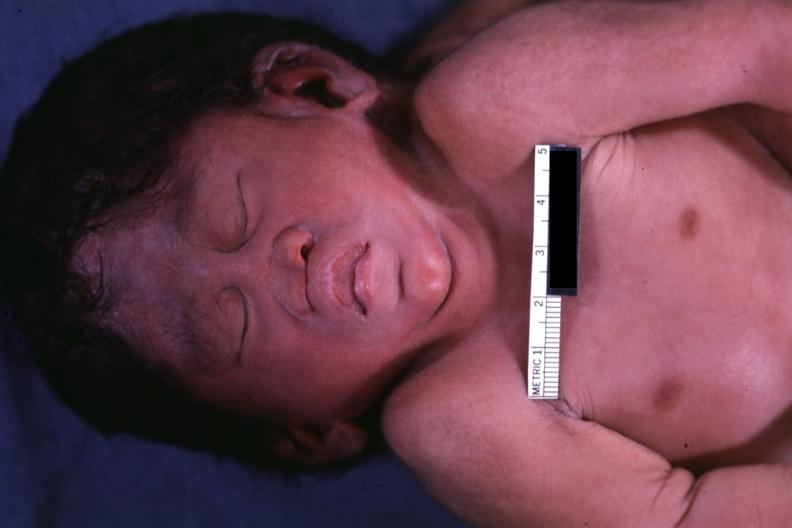s conjoined twins cephalothoracopagus janiceps present?
Answer the question using a single word or phrase. Yes 